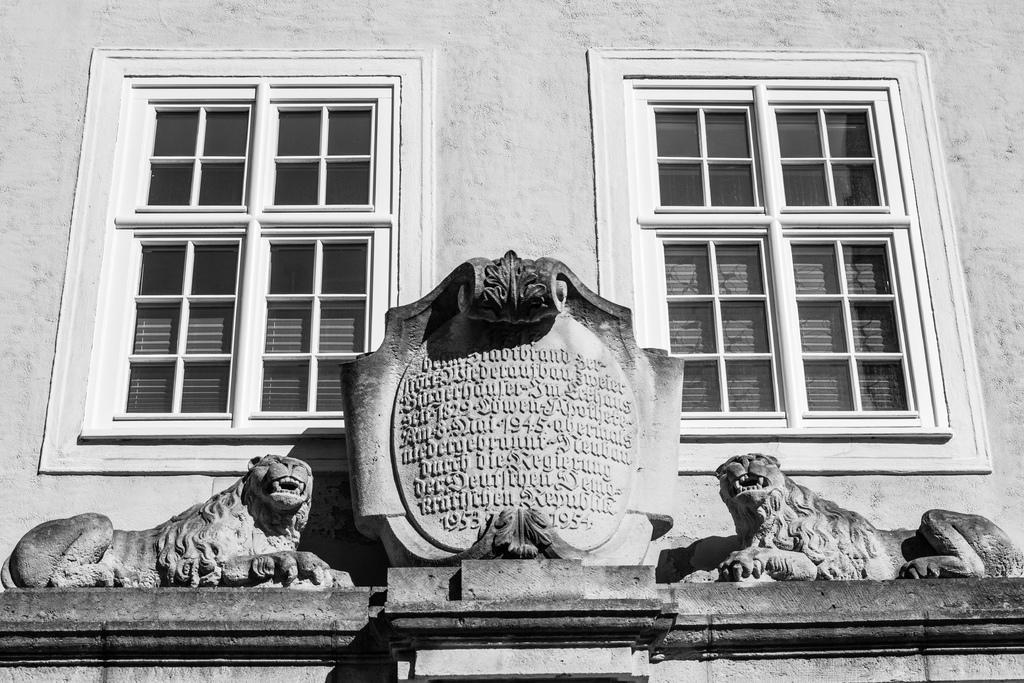How would you summarize this image in a sentence or two? In this image in the front there are statues of the animal and there is a memorial stone in which some text is written on it. In the background there are windows and there is a wall. 